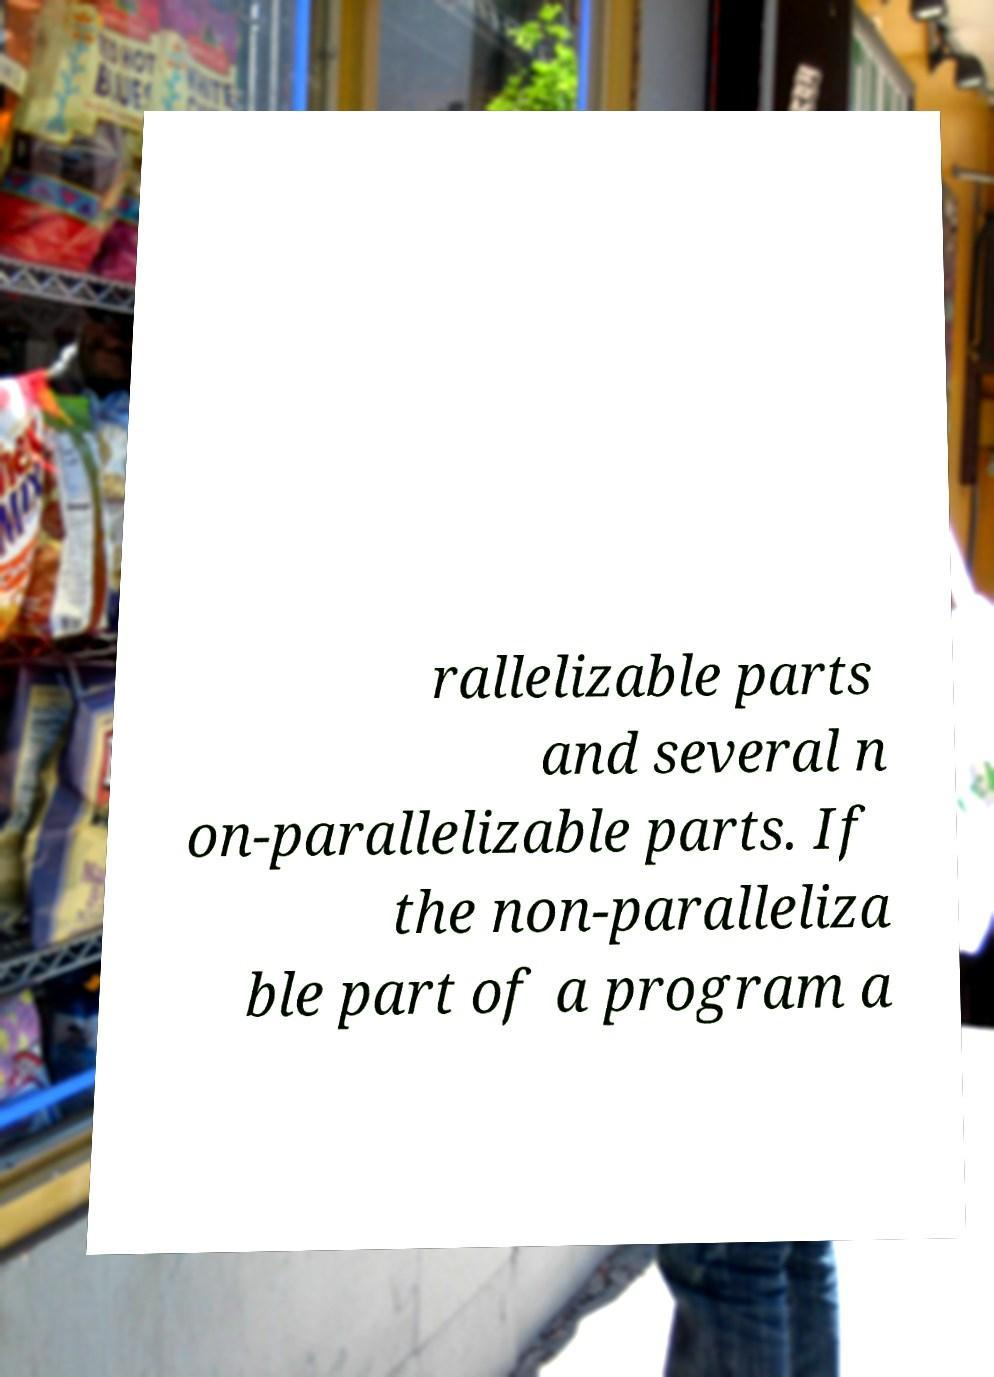For documentation purposes, I need the text within this image transcribed. Could you provide that? rallelizable parts and several n on-parallelizable parts. If the non-paralleliza ble part of a program a 